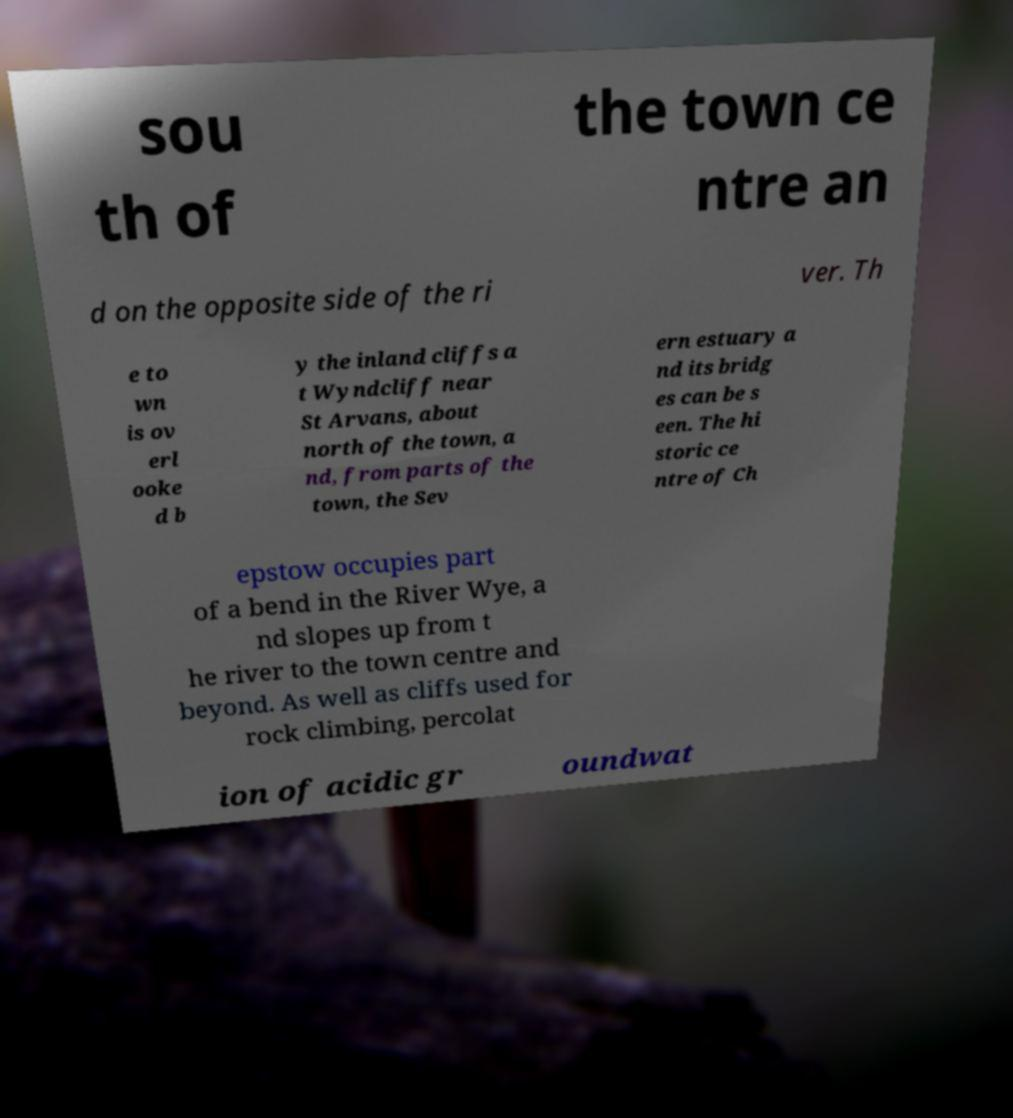Could you extract and type out the text from this image? sou th of the town ce ntre an d on the opposite side of the ri ver. Th e to wn is ov erl ooke d b y the inland cliffs a t Wyndcliff near St Arvans, about north of the town, a nd, from parts of the town, the Sev ern estuary a nd its bridg es can be s een. The hi storic ce ntre of Ch epstow occupies part of a bend in the River Wye, a nd slopes up from t he river to the town centre and beyond. As well as cliffs used for rock climbing, percolat ion of acidic gr oundwat 